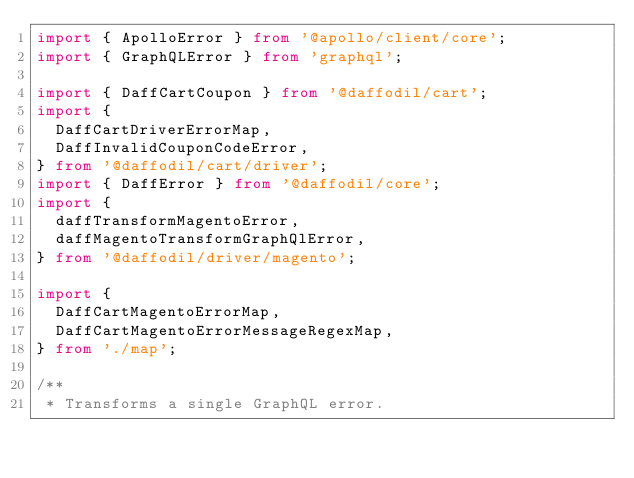Convert code to text. <code><loc_0><loc_0><loc_500><loc_500><_TypeScript_>import { ApolloError } from '@apollo/client/core';
import { GraphQLError } from 'graphql';

import { DaffCartCoupon } from '@daffodil/cart';
import {
  DaffCartDriverErrorMap,
  DaffInvalidCouponCodeError,
} from '@daffodil/cart/driver';
import { DaffError } from '@daffodil/core';
import {
  daffTransformMagentoError,
  daffMagentoTransformGraphQlError,
} from '@daffodil/driver/magento';

import {
  DaffCartMagentoErrorMap,
  DaffCartMagentoErrorMessageRegexMap,
} from './map';

/**
 * Transforms a single GraphQL error.</code> 